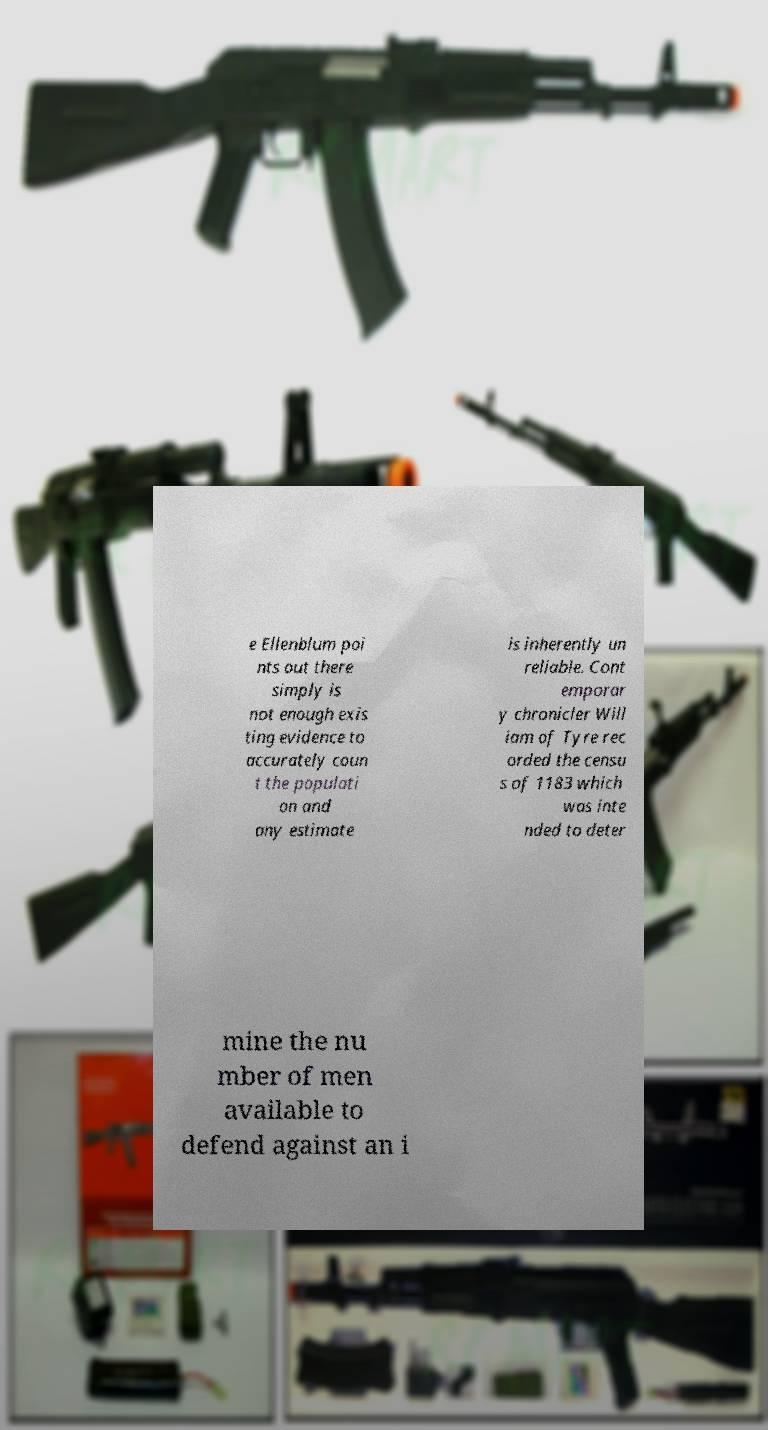Can you read and provide the text displayed in the image?This photo seems to have some interesting text. Can you extract and type it out for me? e Ellenblum poi nts out there simply is not enough exis ting evidence to accurately coun t the populati on and any estimate is inherently un reliable. Cont emporar y chronicler Will iam of Tyre rec orded the censu s of 1183 which was inte nded to deter mine the nu mber of men available to defend against an i 